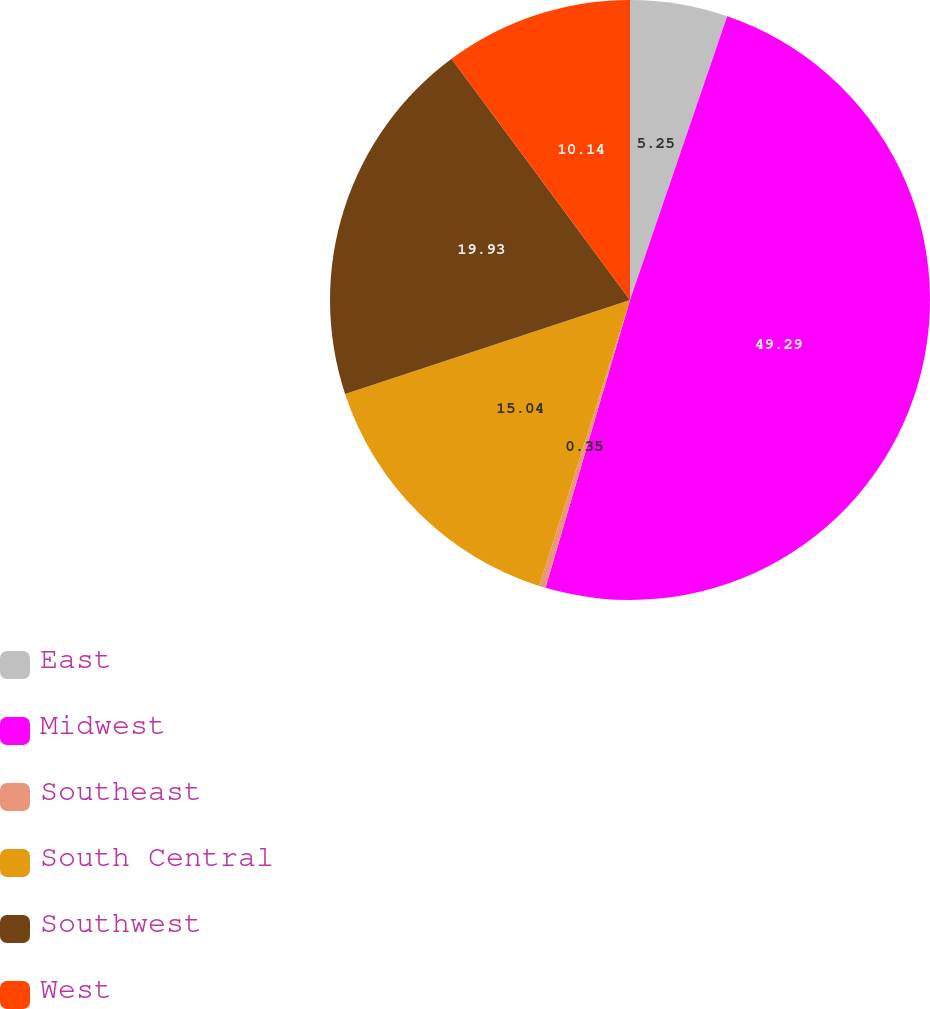Convert chart to OTSL. <chart><loc_0><loc_0><loc_500><loc_500><pie_chart><fcel>East<fcel>Midwest<fcel>Southeast<fcel>South Central<fcel>Southwest<fcel>West<nl><fcel>5.25%<fcel>49.3%<fcel>0.35%<fcel>15.04%<fcel>19.93%<fcel>10.14%<nl></chart> 